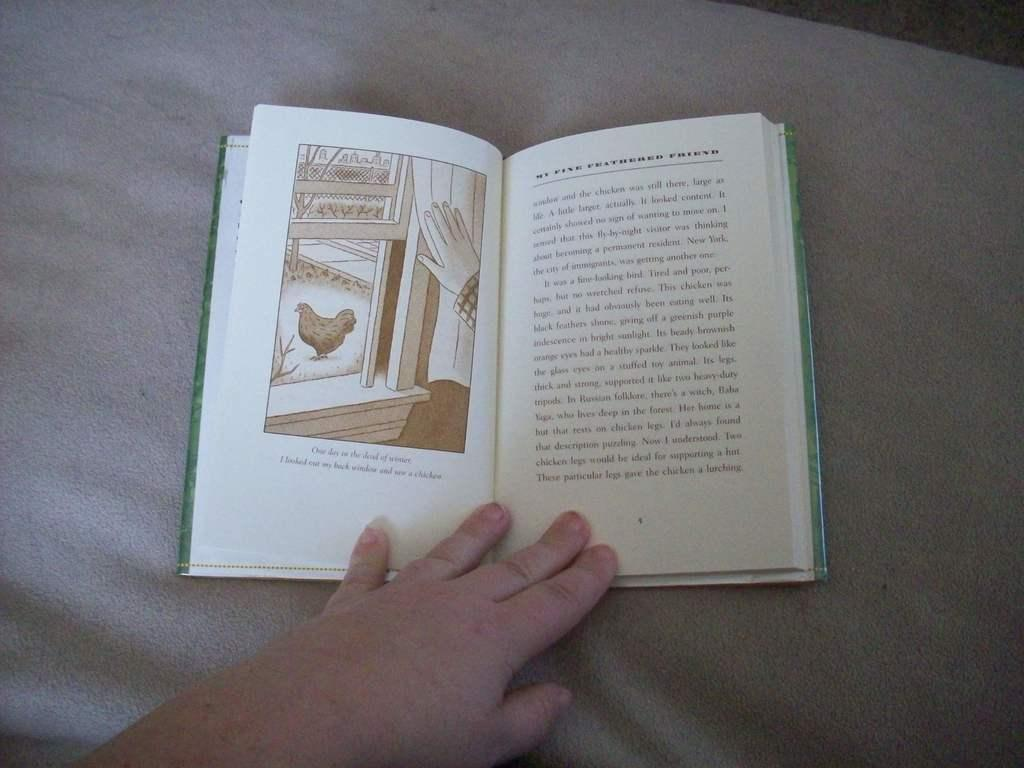<image>
Summarize the visual content of the image. An open hardback book titled My Fine Feathered Friend 